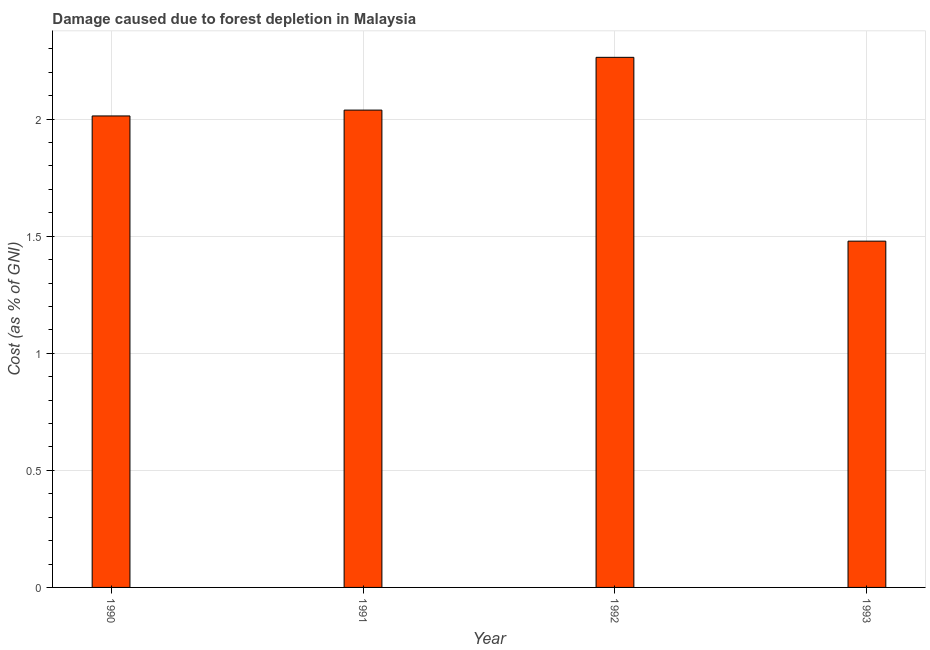Does the graph contain any zero values?
Your answer should be very brief. No. What is the title of the graph?
Make the answer very short. Damage caused due to forest depletion in Malaysia. What is the label or title of the Y-axis?
Your answer should be compact. Cost (as % of GNI). What is the damage caused due to forest depletion in 1990?
Make the answer very short. 2.01. Across all years, what is the maximum damage caused due to forest depletion?
Ensure brevity in your answer.  2.26. Across all years, what is the minimum damage caused due to forest depletion?
Your answer should be very brief. 1.48. In which year was the damage caused due to forest depletion maximum?
Ensure brevity in your answer.  1992. In which year was the damage caused due to forest depletion minimum?
Your response must be concise. 1993. What is the sum of the damage caused due to forest depletion?
Your response must be concise. 7.79. What is the difference between the damage caused due to forest depletion in 1991 and 1992?
Ensure brevity in your answer.  -0.23. What is the average damage caused due to forest depletion per year?
Provide a succinct answer. 1.95. What is the median damage caused due to forest depletion?
Keep it short and to the point. 2.03. In how many years, is the damage caused due to forest depletion greater than 2 %?
Ensure brevity in your answer.  3. What is the ratio of the damage caused due to forest depletion in 1991 to that in 1993?
Offer a very short reply. 1.38. Is the damage caused due to forest depletion in 1990 less than that in 1991?
Give a very brief answer. Yes. Is the difference between the damage caused due to forest depletion in 1991 and 1992 greater than the difference between any two years?
Provide a succinct answer. No. What is the difference between the highest and the second highest damage caused due to forest depletion?
Your response must be concise. 0.23. Is the sum of the damage caused due to forest depletion in 1990 and 1991 greater than the maximum damage caused due to forest depletion across all years?
Offer a terse response. Yes. What is the difference between the highest and the lowest damage caused due to forest depletion?
Offer a very short reply. 0.79. In how many years, is the damage caused due to forest depletion greater than the average damage caused due to forest depletion taken over all years?
Your response must be concise. 3. How many bars are there?
Keep it short and to the point. 4. Are all the bars in the graph horizontal?
Your answer should be compact. No. How many years are there in the graph?
Your response must be concise. 4. Are the values on the major ticks of Y-axis written in scientific E-notation?
Offer a terse response. No. What is the Cost (as % of GNI) of 1990?
Your answer should be very brief. 2.01. What is the Cost (as % of GNI) of 1991?
Keep it short and to the point. 2.04. What is the Cost (as % of GNI) in 1992?
Offer a terse response. 2.26. What is the Cost (as % of GNI) of 1993?
Give a very brief answer. 1.48. What is the difference between the Cost (as % of GNI) in 1990 and 1991?
Your answer should be compact. -0.02. What is the difference between the Cost (as % of GNI) in 1990 and 1992?
Provide a succinct answer. -0.25. What is the difference between the Cost (as % of GNI) in 1990 and 1993?
Offer a terse response. 0.53. What is the difference between the Cost (as % of GNI) in 1991 and 1992?
Provide a short and direct response. -0.23. What is the difference between the Cost (as % of GNI) in 1991 and 1993?
Make the answer very short. 0.56. What is the difference between the Cost (as % of GNI) in 1992 and 1993?
Your answer should be very brief. 0.79. What is the ratio of the Cost (as % of GNI) in 1990 to that in 1991?
Your answer should be very brief. 0.99. What is the ratio of the Cost (as % of GNI) in 1990 to that in 1992?
Provide a short and direct response. 0.89. What is the ratio of the Cost (as % of GNI) in 1990 to that in 1993?
Offer a terse response. 1.36. What is the ratio of the Cost (as % of GNI) in 1991 to that in 1992?
Your answer should be very brief. 0.9. What is the ratio of the Cost (as % of GNI) in 1991 to that in 1993?
Ensure brevity in your answer.  1.38. What is the ratio of the Cost (as % of GNI) in 1992 to that in 1993?
Offer a terse response. 1.53. 